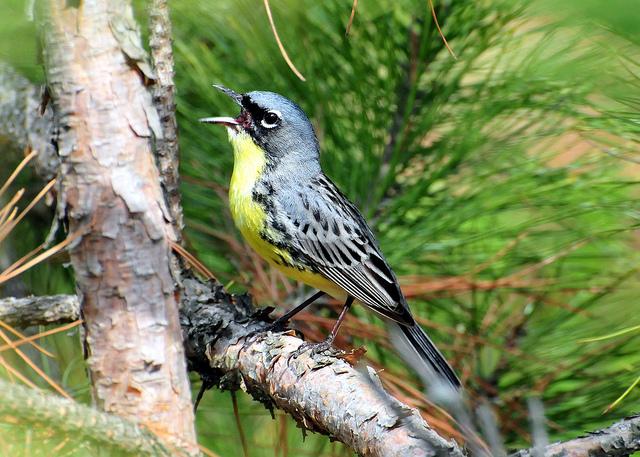What color is the bird's breast?
Be succinct. Yellow. What is the bird sitting on?
Keep it brief. Branch. What is the bird doing?
Be succinct. Chirping. 